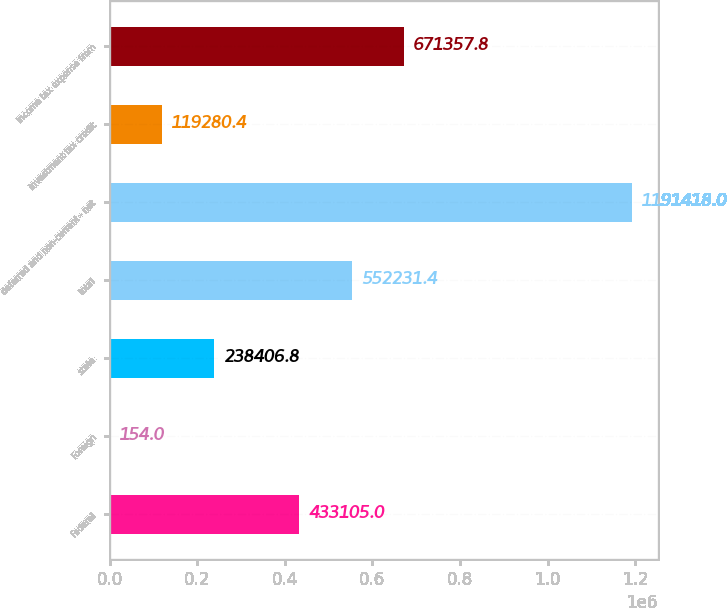<chart> <loc_0><loc_0><loc_500><loc_500><bar_chart><fcel>Federal<fcel>Foreign<fcel>state<fcel>total<fcel>deferred and non-current - net<fcel>investment tax credit<fcel>Income tax expense from<nl><fcel>433105<fcel>154<fcel>238407<fcel>552231<fcel>1.19142e+06<fcel>119280<fcel>671358<nl></chart> 